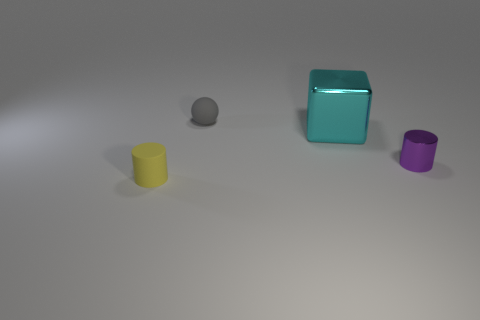What is the color of the small thing that is both in front of the small gray sphere and on the left side of the tiny purple metallic cylinder?
Your response must be concise. Yellow. How many things are small metal blocks or tiny spheres?
Your response must be concise. 1. How many big things are yellow matte cylinders or cyan metal things?
Your answer should be compact. 1. What is the size of the object that is both on the left side of the big block and in front of the tiny matte sphere?
Keep it short and to the point. Small. What shape is the tiny thing that is in front of the gray sphere and on the left side of the cyan cube?
Provide a short and direct response. Cylinder. Is the size of the object that is on the right side of the cyan block the same as the big cyan metallic thing?
Your response must be concise. No. What is the material of the other thing that is the same shape as the small yellow matte object?
Your answer should be compact. Metal. Does the tiny yellow object have the same shape as the purple metallic object?
Keep it short and to the point. Yes. There is a small rubber object that is on the left side of the gray object; how many gray matte things are in front of it?
Offer a terse response. 0. The tiny object that is the same material as the large cyan cube is what shape?
Make the answer very short. Cylinder. 